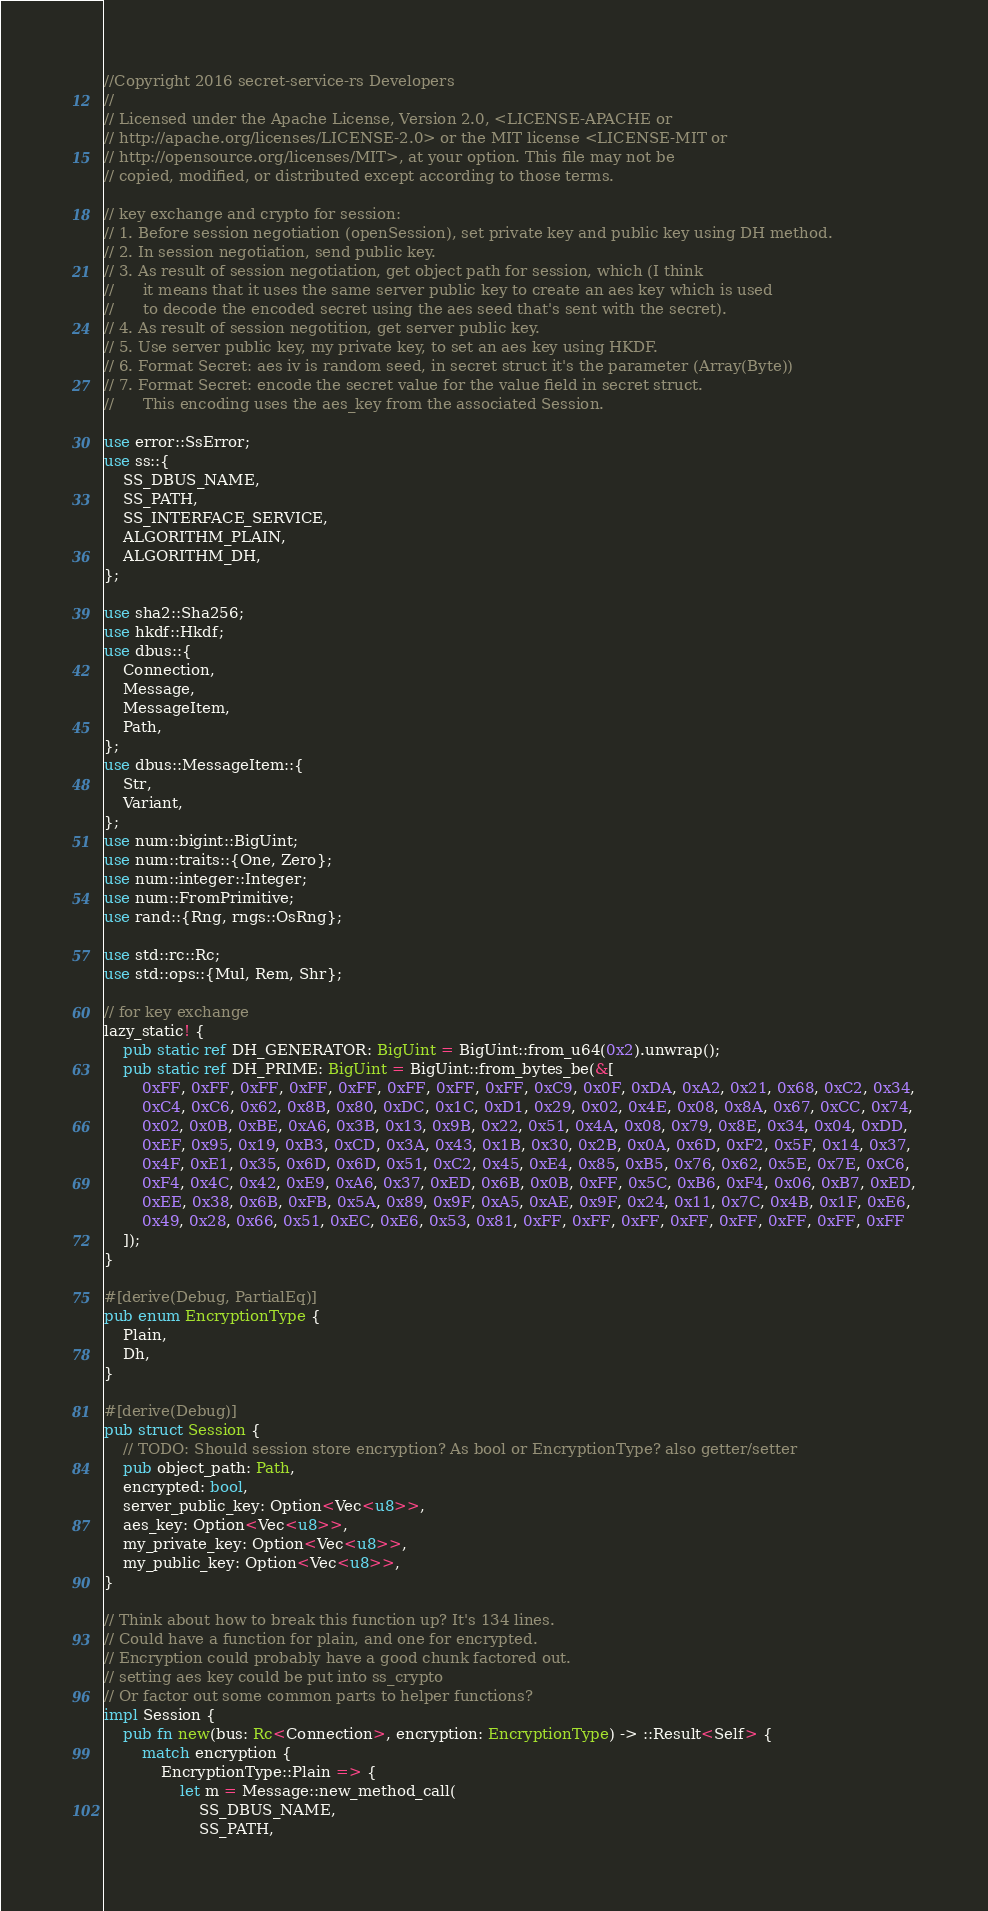<code> <loc_0><loc_0><loc_500><loc_500><_Rust_>//Copyright 2016 secret-service-rs Developers
//
// Licensed under the Apache License, Version 2.0, <LICENSE-APACHE or
// http://apache.org/licenses/LICENSE-2.0> or the MIT license <LICENSE-MIT or
// http://opensource.org/licenses/MIT>, at your option. This file may not be
// copied, modified, or distributed except according to those terms.

// key exchange and crypto for session:
// 1. Before session negotiation (openSession), set private key and public key using DH method.
// 2. In session negotiation, send public key.
// 3. As result of session negotiation, get object path for session, which (I think
//      it means that it uses the same server public key to create an aes key which is used
//      to decode the encoded secret using the aes seed that's sent with the secret).
// 4. As result of session negotition, get server public key.
// 5. Use server public key, my private key, to set an aes key using HKDF.
// 6. Format Secret: aes iv is random seed, in secret struct it's the parameter (Array(Byte))
// 7. Format Secret: encode the secret value for the value field in secret struct. 
//      This encoding uses the aes_key from the associated Session.

use error::SsError;
use ss::{
    SS_DBUS_NAME,
    SS_PATH,
    SS_INTERFACE_SERVICE,
    ALGORITHM_PLAIN,
    ALGORITHM_DH,
};

use sha2::Sha256;
use hkdf::Hkdf;
use dbus::{
    Connection,
    Message,
    MessageItem,
    Path,
};
use dbus::MessageItem::{
    Str,
    Variant,
};
use num::bigint::BigUint;
use num::traits::{One, Zero};
use num::integer::Integer;
use num::FromPrimitive;
use rand::{Rng, rngs::OsRng};

use std::rc::Rc;
use std::ops::{Mul, Rem, Shr};

// for key exchange
lazy_static! {
    pub static ref DH_GENERATOR: BigUint = BigUint::from_u64(0x2).unwrap();
    pub static ref DH_PRIME: BigUint = BigUint::from_bytes_be(&[
        0xFF, 0xFF, 0xFF, 0xFF, 0xFF, 0xFF, 0xFF, 0xFF, 0xC9, 0x0F, 0xDA, 0xA2, 0x21, 0x68, 0xC2, 0x34,
        0xC4, 0xC6, 0x62, 0x8B, 0x80, 0xDC, 0x1C, 0xD1, 0x29, 0x02, 0x4E, 0x08, 0x8A, 0x67, 0xCC, 0x74,
        0x02, 0x0B, 0xBE, 0xA6, 0x3B, 0x13, 0x9B, 0x22, 0x51, 0x4A, 0x08, 0x79, 0x8E, 0x34, 0x04, 0xDD,
        0xEF, 0x95, 0x19, 0xB3, 0xCD, 0x3A, 0x43, 0x1B, 0x30, 0x2B, 0x0A, 0x6D, 0xF2, 0x5F, 0x14, 0x37,
        0x4F, 0xE1, 0x35, 0x6D, 0x6D, 0x51, 0xC2, 0x45, 0xE4, 0x85, 0xB5, 0x76, 0x62, 0x5E, 0x7E, 0xC6,
        0xF4, 0x4C, 0x42, 0xE9, 0xA6, 0x37, 0xED, 0x6B, 0x0B, 0xFF, 0x5C, 0xB6, 0xF4, 0x06, 0xB7, 0xED,
        0xEE, 0x38, 0x6B, 0xFB, 0x5A, 0x89, 0x9F, 0xA5, 0xAE, 0x9F, 0x24, 0x11, 0x7C, 0x4B, 0x1F, 0xE6,
        0x49, 0x28, 0x66, 0x51, 0xEC, 0xE6, 0x53, 0x81, 0xFF, 0xFF, 0xFF, 0xFF, 0xFF, 0xFF, 0xFF, 0xFF
    ]);
}

#[derive(Debug, PartialEq)]
pub enum EncryptionType {
    Plain,
    Dh,
}

#[derive(Debug)]
pub struct Session {
    // TODO: Should session store encryption? As bool or EncryptionType? also getter/setter
    pub object_path: Path,
    encrypted: bool,
    server_public_key: Option<Vec<u8>>,
    aes_key: Option<Vec<u8>>,
    my_private_key: Option<Vec<u8>>,
    my_public_key: Option<Vec<u8>>,
}

// Think about how to break this function up? It's 134 lines.
// Could have a function for plain, and one for encrypted.
// Encryption could probably have a good chunk factored out.
// setting aes key could be put into ss_crypto
// Or factor out some common parts to helper functions?
impl Session {
    pub fn new(bus: Rc<Connection>, encryption: EncryptionType) -> ::Result<Self> {
        match encryption {
            EncryptionType::Plain => {
                let m = Message::new_method_call(
                    SS_DBUS_NAME,
                    SS_PATH,</code> 